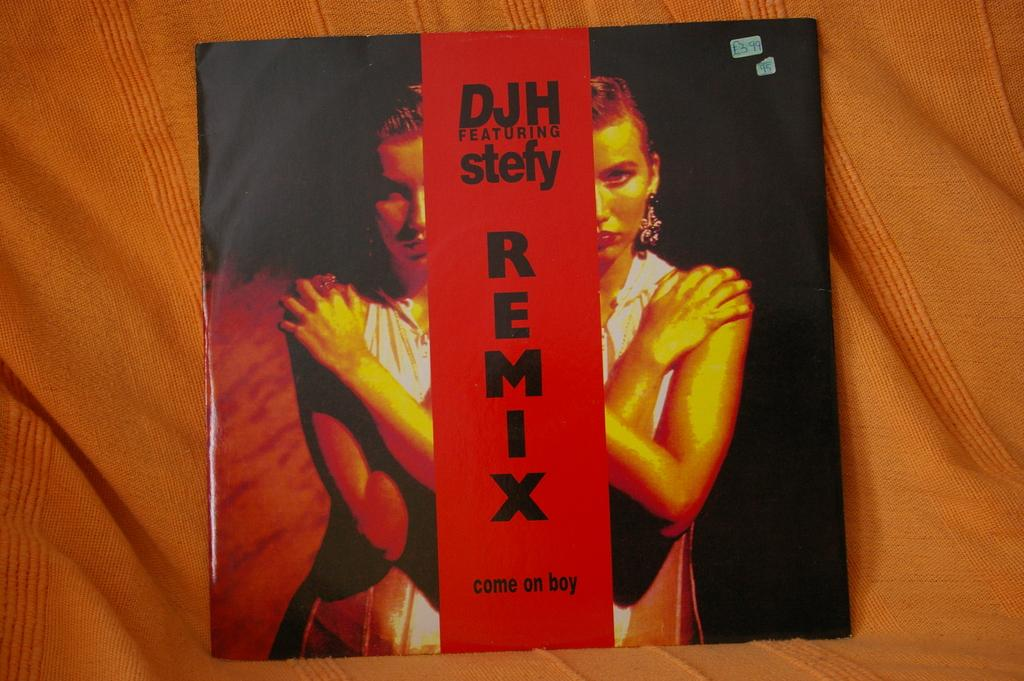<image>
Give a short and clear explanation of the subsequent image. An album cover with a remix from DJH featuring Stefy. 